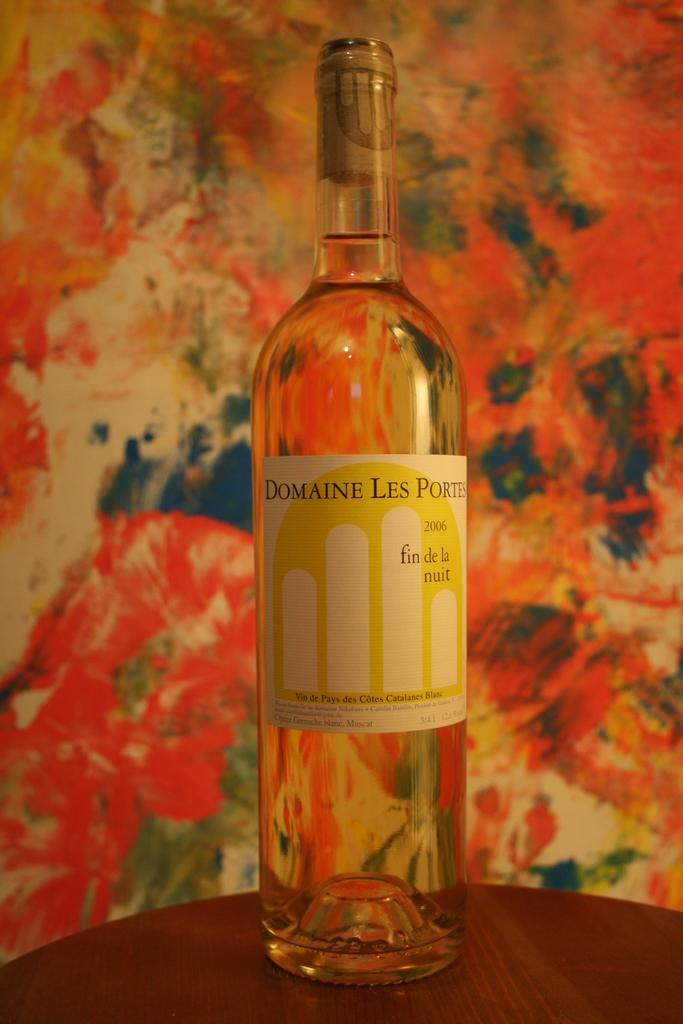Provide a one-sentence caption for the provided image. Bottle of Domaine Les Ports that is full and never open. 